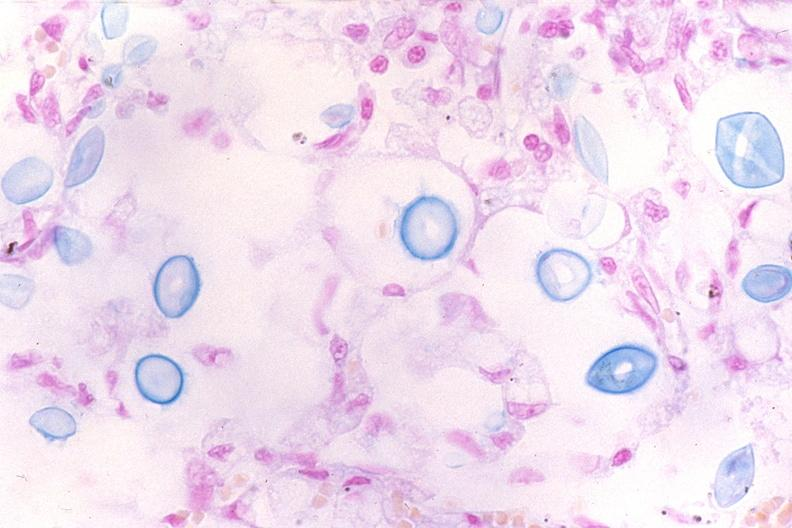do acute myelogenous leukemia stain?
Answer the question using a single word or phrase. No 